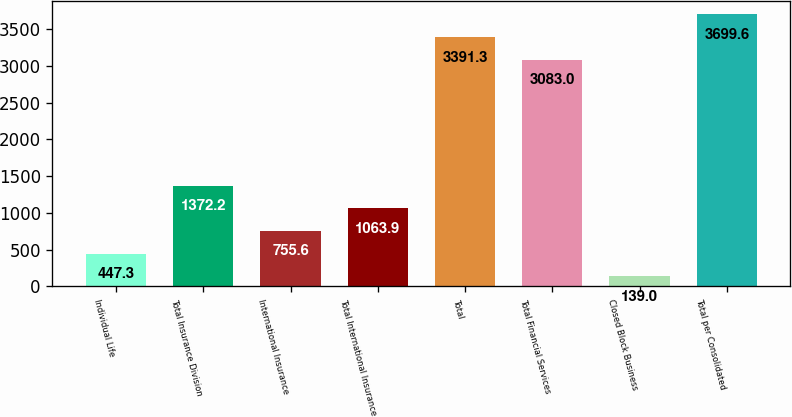Convert chart. <chart><loc_0><loc_0><loc_500><loc_500><bar_chart><fcel>Individual Life<fcel>Total Insurance Division<fcel>International Insurance<fcel>Total International Insurance<fcel>Total<fcel>Total Financial Services<fcel>Closed Block Business<fcel>Total per Consolidated<nl><fcel>447.3<fcel>1372.2<fcel>755.6<fcel>1063.9<fcel>3391.3<fcel>3083<fcel>139<fcel>3699.6<nl></chart> 